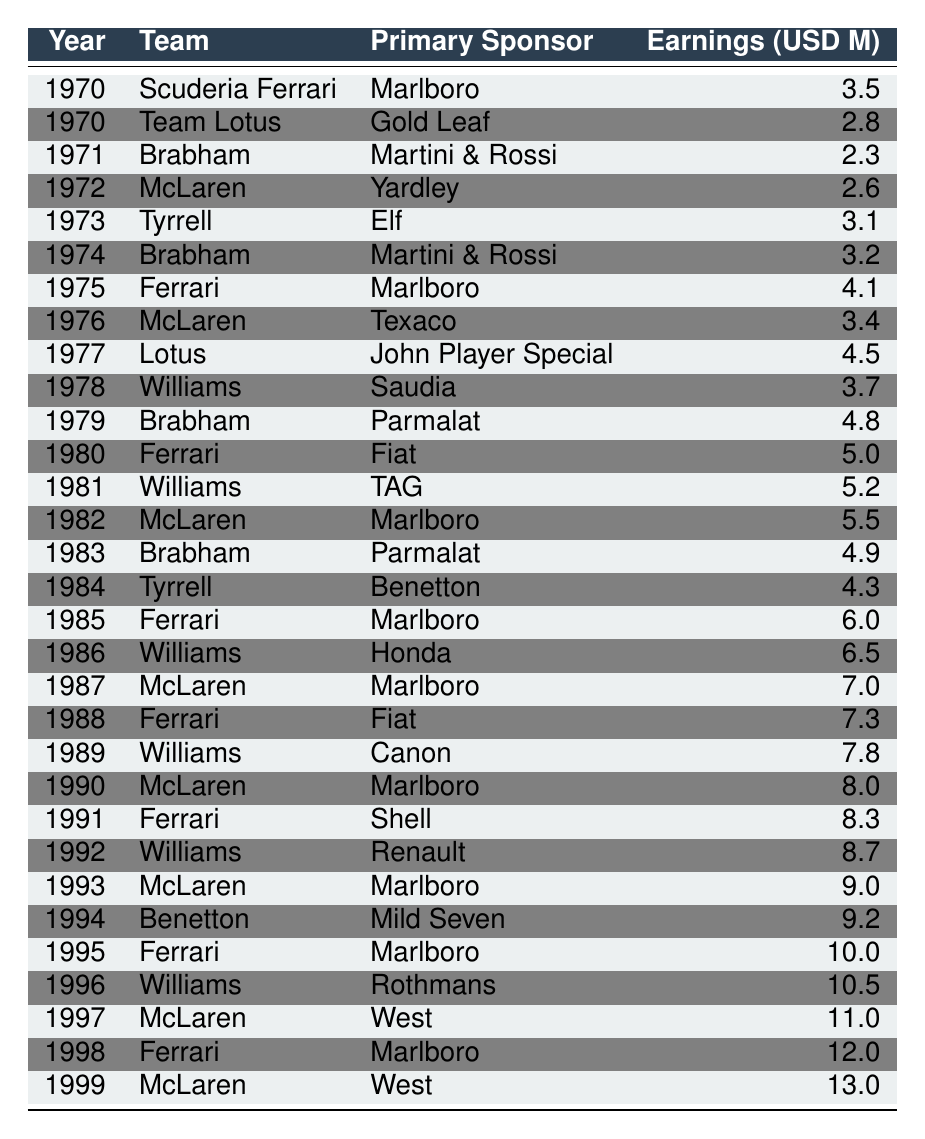What was the highest sponsorship earnings in 1999? In the table, the entry for 1999 shows that McLaren had sponsorship earnings of 13.0 million USD. This is the maximum value for the year 1999.
Answer: 13.0 million USD Which team earned the most from sponsorship in 1985? The entry for 1985 indicates that Ferrari earned 6.0 million USD, making it the highest among the listed teams for that year.
Answer: Ferrari earned 6.0 million USD True or False: The primary sponsor of Williams in 1996 was Honda. Referring to the table for the year 1996, it is evident that Williams' primary sponsor was Rothmans, not Honda. Therefore, the statement is false.
Answer: False What were the total sponsorship earnings for Ferrari from 1970 to 1999? To find Ferrari's total earnings, we add its earnings from all entries: 3.5 (1970) + 4.1 (1975) + 5.0 (1980) + 6.0 (1985) + 7.3 (1988) + 8.3 (1991) + 10.0 (1995) + 12.0 (1998) = 56.2 million USD.
Answer: 56.2 million USD Which team had the highest single-year earnings and in which year did it occur? By inspecting the entries, we see that McLaren had the highest earnings in 1999, which was 13.0 million USD. This is greater than any other team's earnings in any other year.
Answer: McLaren in 1999 with 13.0 million USD How many times did McLaren earn more than 10 million USD from sponsorship? We identify the years where McLaren earned over 10 million USD: 1997 with 11.0 million USD and 1999 with 13.0 million USD. Therefore, McLaren achieved this twice.
Answer: Twice What was the average sponsorship earnings of Williams throughout the years listed? Williams had three entries: 3.7 (1978), 5.2 (1981), 6.5 (1986), 7.8 (1989), 8.7 (1992), and 10.5 (1996). Summing these values gives us 3.7 + 5.2 + 6.5 + 7.8 + 8.7 + 10.5 = 42.4 million USD. Dividing by 6 yields an average of 42.4 / 6 = 7.07 million USD.
Answer: 7.07 million USD Did Brabham ever earn more than Ferrari in the same year? Analyzing both teams' entries reveals that in 1979, Brabham earned 4.8 million USD while Ferrari earned 5.0 million USD; thus, Brabham never outperformed Ferrari in sponsorship in a shared year.
Answer: No 